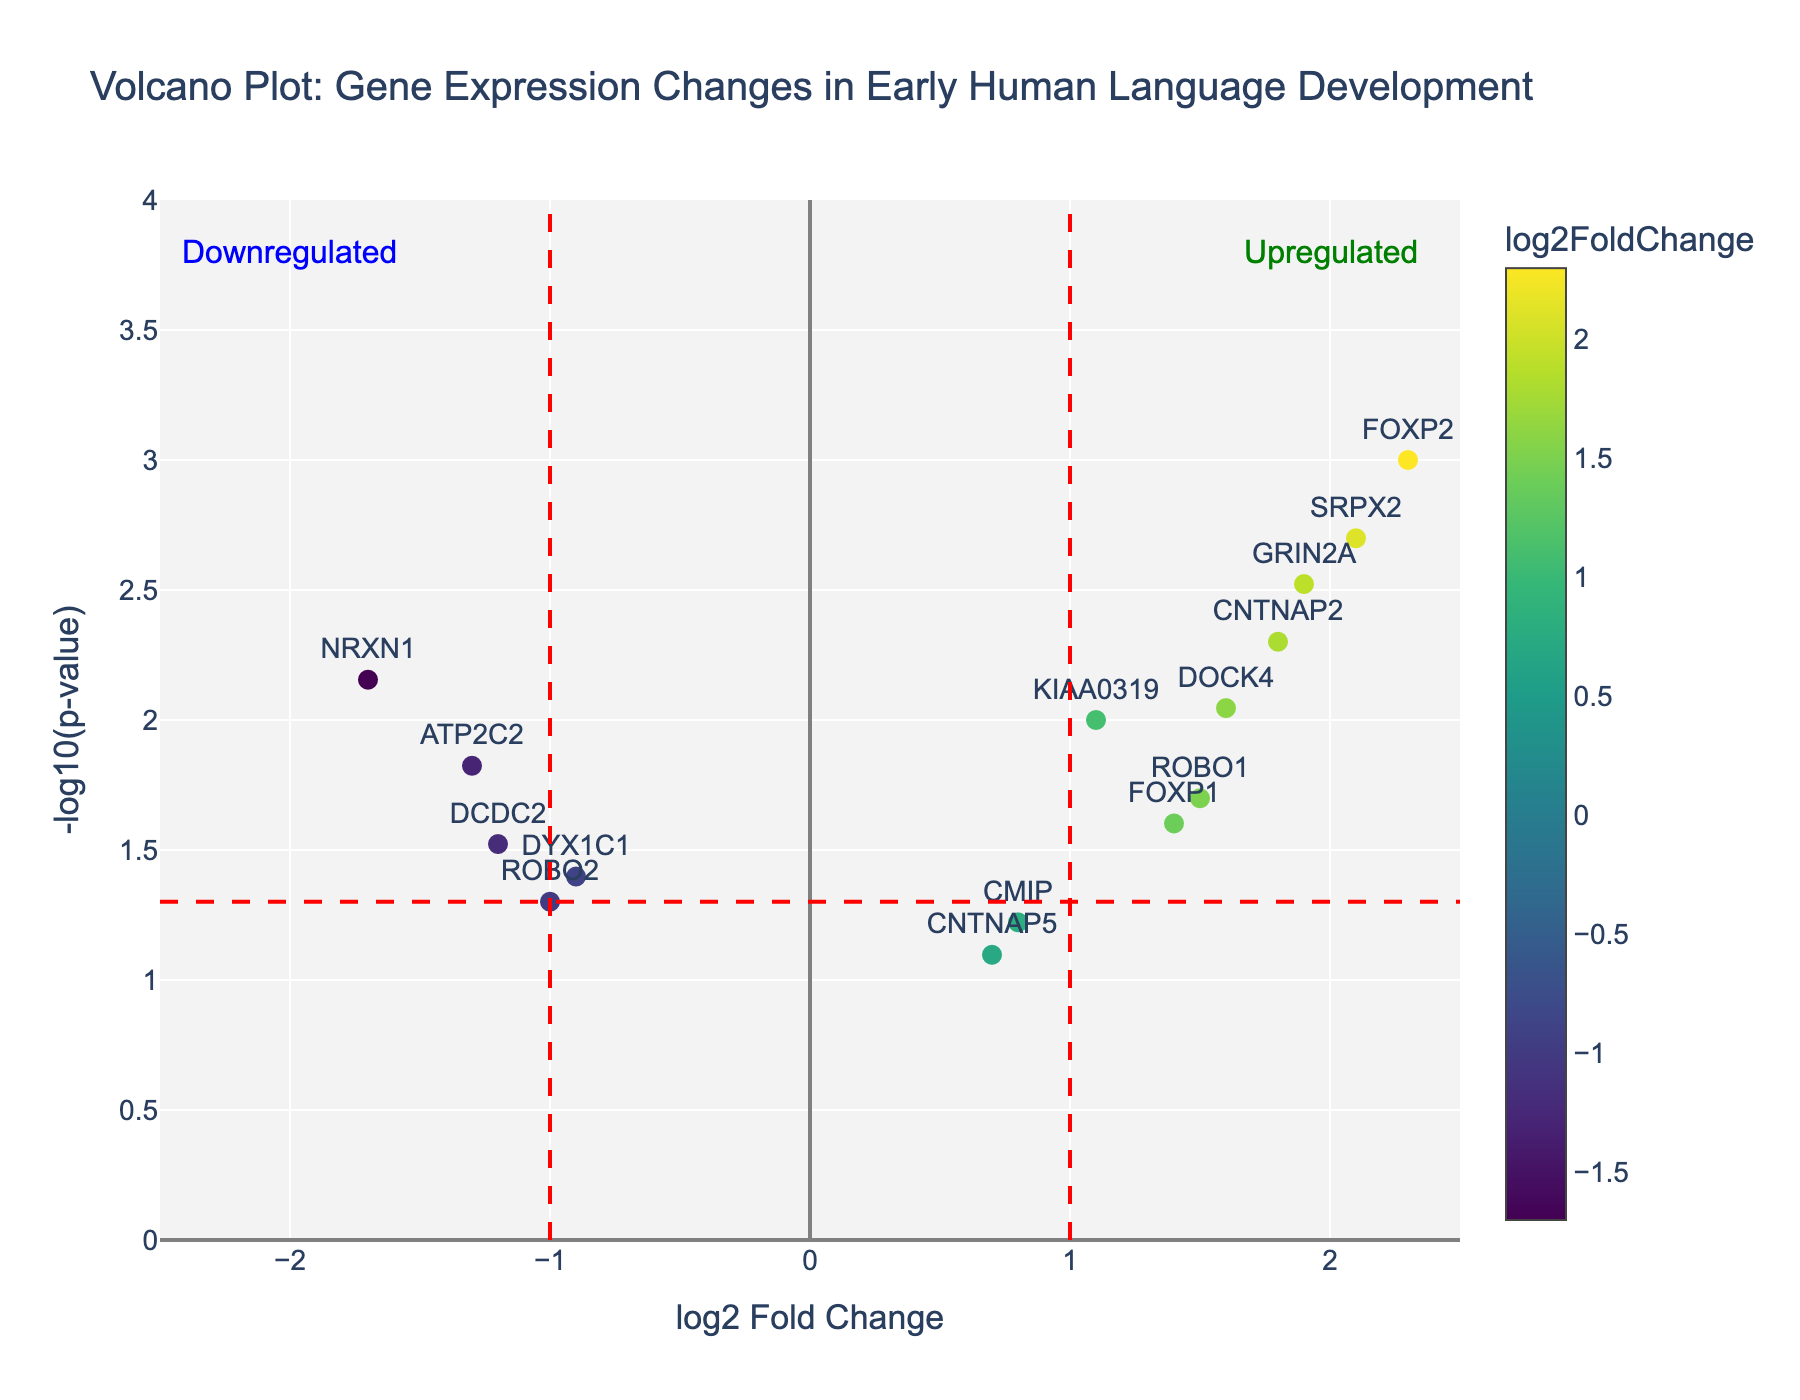What's the title of the figure? The title is clearly displayed at the top of the figure.
Answer: Volcano Plot: Gene Expression Changes in Early Human Language Development What are the ranges of the x and y axes? The x-axis ranges from -2.5 to 2.5, and the y-axis ranges from 0 to 4, as shown by the axis labels and tick marks.
Answer: x-axis: -2.5 to 2.5, y-axis: 0 to 4 How many genes have a log2 fold change greater than 1 and a p-value less than 0.05? First, find genes positioned to the right of the vertical line at x=1, then check which of these have a p-value less than 0.05 (above y threshold line). There are four genes: FOXP2, CNTNAP2, SRPX2, GRIN2A.
Answer: 4 Which gene has the highest log2 fold change and what is its -log10(p-value)? Identify the gene at the farthest right on the plot, which is FOXP2. Check its y-coordinate for -log10(p-value). The value is approximately 3.
Answer: FOXP2, ~3 What color indicates genes with a negative log2 fold change? The plot’s color scale suggests that more negative log2 fold changes are represented by darker colors.
Answer: Darker colors (closer to blue) How many genes are significantly downregulated (log2FC < -1 and p-value < 0.05)? Look left of the vertical line at x=-1 and above the horizontal significance line. These genes are DYX1C1, NRXN1, and ATP2C2.
Answer: 3 Which gene is closer to the x-axis but still significant in terms of p-value (low log2 fold change but below p-value threshold)? Identify the low log2FC but significant gene, which is ROBO1 with log2FC of 1.5 and a p-value of 0.02.
Answer: ROBO1 Among the genes with a log2 fold change of at least 1, which one has the weakest significance (highest p-value)? Find genes with log2FC ≥ 1 and identify the highest p-value (lowest y-coordinate). DOCK4 has a log2FC of 1.6 and a p-value of 0.009 (-log10(p-value) ≈ 2).
Answer: DOCK4 